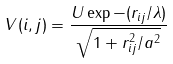<formula> <loc_0><loc_0><loc_500><loc_500>V ( i , j ) = { \frac { U \exp - ( r _ { i j } / \lambda ) } { \sqrt { 1 + r _ { i j } ^ { 2 } / a ^ { 2 } } } }</formula> 